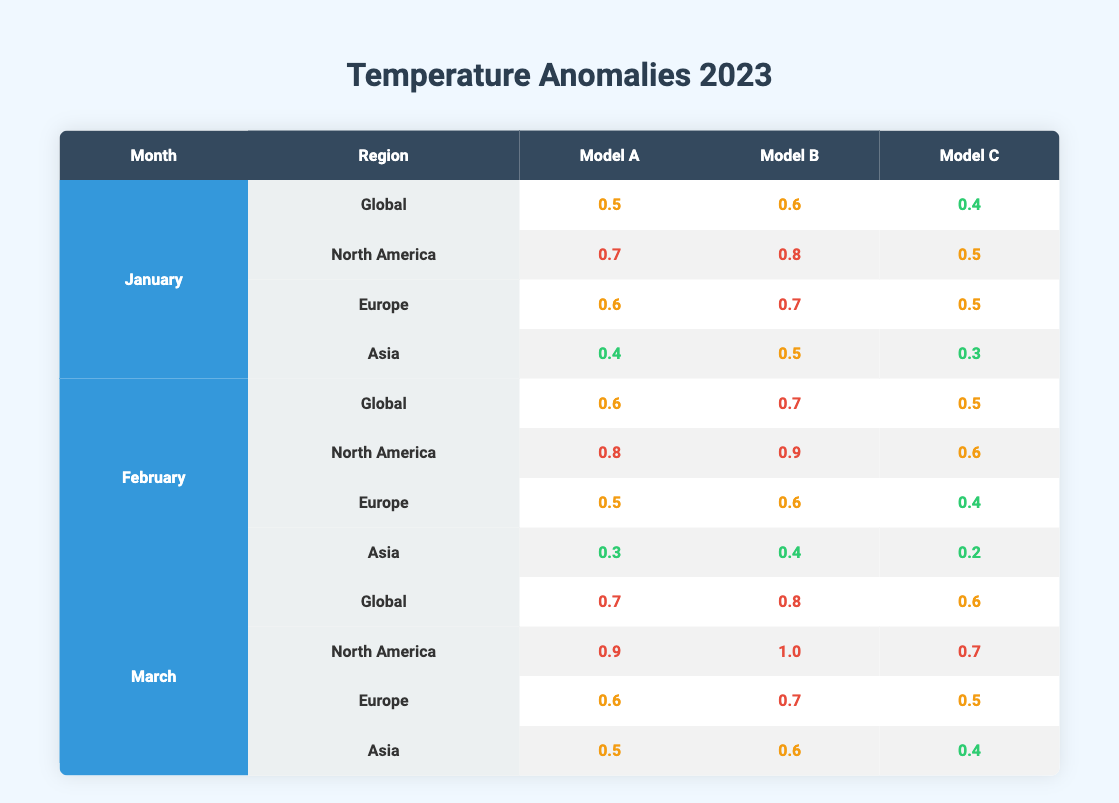What is the temperature anomaly for North America in February according to Model B? The table shows the temperature anomaly for North America in February under Model B, which is directly listed as 0.9.
Answer: 0.9 Which region had the highest temperature anomaly in January according to Model A? By examining the values in January under Model A, North America has the highest anomaly at 0.7 compared to 0.6 for Europe, 0.5 for Global, and 0.4 for Asia.
Answer: North America What is the average temperature anomaly for Asia across all models in March? For March, the values for Asia across all models are 0.5, 0.6, and 0.4. Adding these gives a total of 1.5, and dividing by 3 gives an average of 0.5.
Answer: 0.5 Did Model C report a higher temperature anomaly for Europe in February compared to January? In February, Model C shows a value of 0.4 for Europe, while in January, Model C has a value of 0.5. Since 0.4 is less than 0.5, the answer is no.
Answer: No How much higher is the average temperature anomaly for Global in January compared to Asia in January using Model B? The Global value for January under Model B is 0.6, and the Asia value is 0.5. Subtracting these gives 0.6 - 0.5 = 0.1. Thus, Global's average is higher than Asia's by 0.1.
Answer: 0.1 Which model reported the lowest temperature anomaly for Global in February? In February, the table shows Model A at 0.6, Model B at 0.7, and Model C at 0.5 for Global. Thus, Model C reported the lowest anomaly.
Answer: Model C Was there an increase in temperature anomalies for North America from January to March according to Model A? January's temperature anomaly for North America under Model A is 0.7, and March's value is 0.9. Since 0.9 is greater than 0.7, the anomaly did increase.
Answer: Yes What is the difference in the temperature anomaly for Europe between February and March according to Model B? The February anomaly for Europe under Model B is 0.6, and in March, it is 0.7. The difference is calculated as 0.7 - 0.6 = 0.1.
Answer: 0.1 